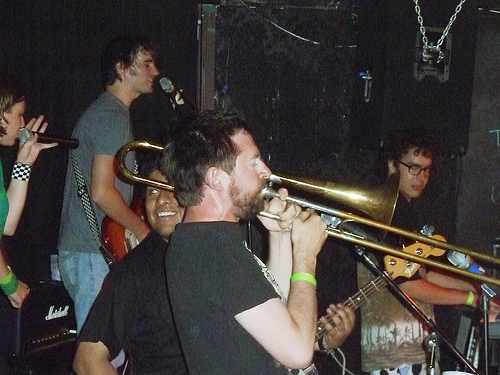<image>
Can you confirm if the man is to the left of the man? Yes. From this viewpoint, the man is positioned to the left side relative to the man. Is there a man to the left of the man? Yes. From this viewpoint, the man is positioned to the left side relative to the man. 